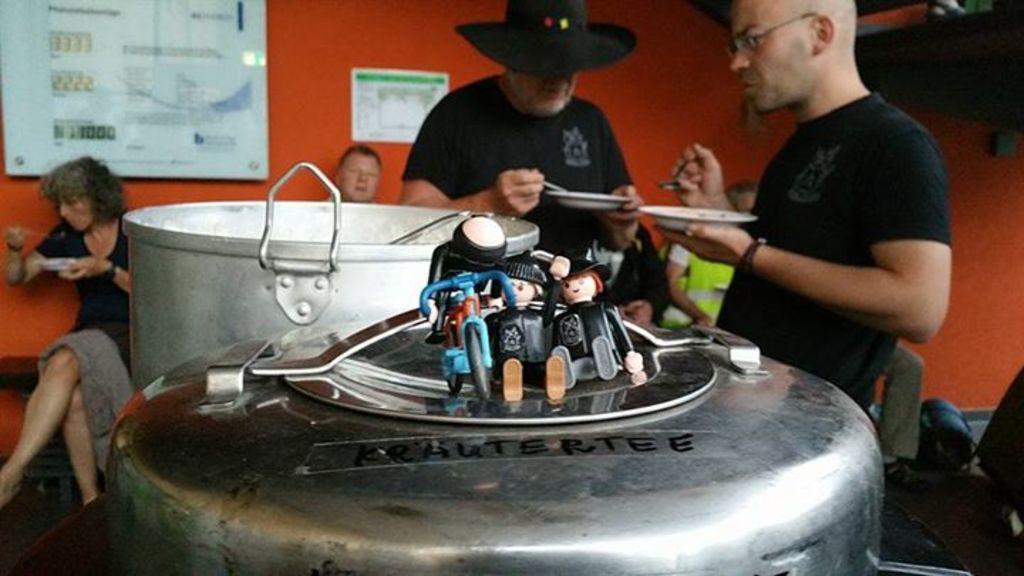How would you summarize this image in a sentence or two? This picture is clicked inside. In the center we can see the toys of persons and a toy of a vehicle is placed on the top of the metal of objects and we can see the containers. On the right we can see the two persons wearing black color t-shirts, holding plates and spoons and standing. In the background we can see the group of persons and some other objects and we can see the wall and the posters hanging on the wall and we can see the text on the posters. 